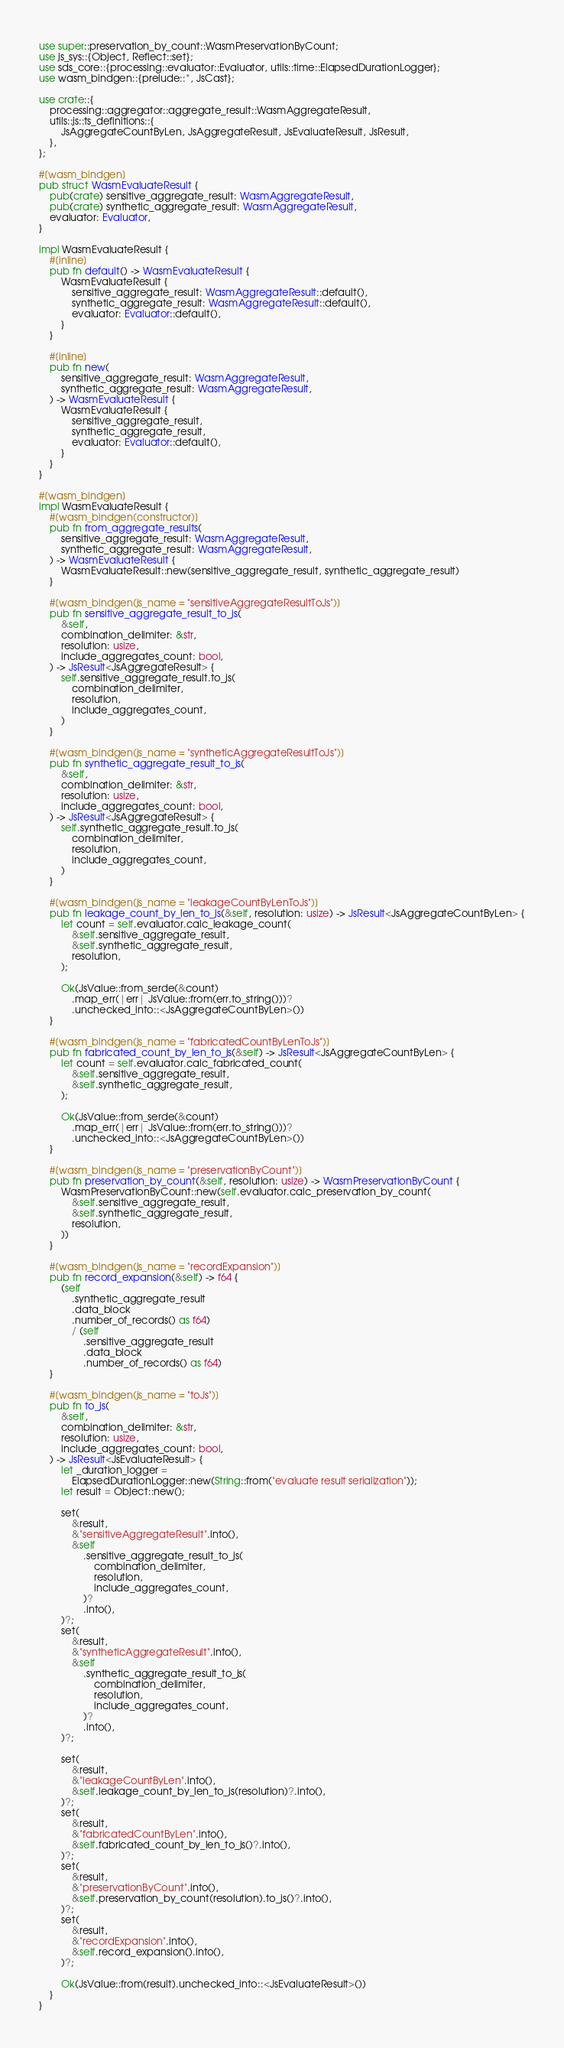<code> <loc_0><loc_0><loc_500><loc_500><_Rust_>use super::preservation_by_count::WasmPreservationByCount;
use js_sys::{Object, Reflect::set};
use sds_core::{processing::evaluator::Evaluator, utils::time::ElapsedDurationLogger};
use wasm_bindgen::{prelude::*, JsCast};

use crate::{
    processing::aggregator::aggregate_result::WasmAggregateResult,
    utils::js::ts_definitions::{
        JsAggregateCountByLen, JsAggregateResult, JsEvaluateResult, JsResult,
    },
};

#[wasm_bindgen]
pub struct WasmEvaluateResult {
    pub(crate) sensitive_aggregate_result: WasmAggregateResult,
    pub(crate) synthetic_aggregate_result: WasmAggregateResult,
    evaluator: Evaluator,
}

impl WasmEvaluateResult {
    #[inline]
    pub fn default() -> WasmEvaluateResult {
        WasmEvaluateResult {
            sensitive_aggregate_result: WasmAggregateResult::default(),
            synthetic_aggregate_result: WasmAggregateResult::default(),
            evaluator: Evaluator::default(),
        }
    }

    #[inline]
    pub fn new(
        sensitive_aggregate_result: WasmAggregateResult,
        synthetic_aggregate_result: WasmAggregateResult,
    ) -> WasmEvaluateResult {
        WasmEvaluateResult {
            sensitive_aggregate_result,
            synthetic_aggregate_result,
            evaluator: Evaluator::default(),
        }
    }
}

#[wasm_bindgen]
impl WasmEvaluateResult {
    #[wasm_bindgen(constructor)]
    pub fn from_aggregate_results(
        sensitive_aggregate_result: WasmAggregateResult,
        synthetic_aggregate_result: WasmAggregateResult,
    ) -> WasmEvaluateResult {
        WasmEvaluateResult::new(sensitive_aggregate_result, synthetic_aggregate_result)
    }

    #[wasm_bindgen(js_name = "sensitiveAggregateResultToJs")]
    pub fn sensitive_aggregate_result_to_js(
        &self,
        combination_delimiter: &str,
        resolution: usize,
        include_aggregates_count: bool,
    ) -> JsResult<JsAggregateResult> {
        self.sensitive_aggregate_result.to_js(
            combination_delimiter,
            resolution,
            include_aggregates_count,
        )
    }

    #[wasm_bindgen(js_name = "syntheticAggregateResultToJs")]
    pub fn synthetic_aggregate_result_to_js(
        &self,
        combination_delimiter: &str,
        resolution: usize,
        include_aggregates_count: bool,
    ) -> JsResult<JsAggregateResult> {
        self.synthetic_aggregate_result.to_js(
            combination_delimiter,
            resolution,
            include_aggregates_count,
        )
    }

    #[wasm_bindgen(js_name = "leakageCountByLenToJs")]
    pub fn leakage_count_by_len_to_js(&self, resolution: usize) -> JsResult<JsAggregateCountByLen> {
        let count = self.evaluator.calc_leakage_count(
            &self.sensitive_aggregate_result,
            &self.synthetic_aggregate_result,
            resolution,
        );

        Ok(JsValue::from_serde(&count)
            .map_err(|err| JsValue::from(err.to_string()))?
            .unchecked_into::<JsAggregateCountByLen>())
    }

    #[wasm_bindgen(js_name = "fabricatedCountByLenToJs")]
    pub fn fabricated_count_by_len_to_js(&self) -> JsResult<JsAggregateCountByLen> {
        let count = self.evaluator.calc_fabricated_count(
            &self.sensitive_aggregate_result,
            &self.synthetic_aggregate_result,
        );

        Ok(JsValue::from_serde(&count)
            .map_err(|err| JsValue::from(err.to_string()))?
            .unchecked_into::<JsAggregateCountByLen>())
    }

    #[wasm_bindgen(js_name = "preservationByCount")]
    pub fn preservation_by_count(&self, resolution: usize) -> WasmPreservationByCount {
        WasmPreservationByCount::new(self.evaluator.calc_preservation_by_count(
            &self.sensitive_aggregate_result,
            &self.synthetic_aggregate_result,
            resolution,
        ))
    }

    #[wasm_bindgen(js_name = "recordExpansion")]
    pub fn record_expansion(&self) -> f64 {
        (self
            .synthetic_aggregate_result
            .data_block
            .number_of_records() as f64)
            / (self
                .sensitive_aggregate_result
                .data_block
                .number_of_records() as f64)
    }

    #[wasm_bindgen(js_name = "toJs")]
    pub fn to_js(
        &self,
        combination_delimiter: &str,
        resolution: usize,
        include_aggregates_count: bool,
    ) -> JsResult<JsEvaluateResult> {
        let _duration_logger =
            ElapsedDurationLogger::new(String::from("evaluate result serialization"));
        let result = Object::new();

        set(
            &result,
            &"sensitiveAggregateResult".into(),
            &self
                .sensitive_aggregate_result_to_js(
                    combination_delimiter,
                    resolution,
                    include_aggregates_count,
                )?
                .into(),
        )?;
        set(
            &result,
            &"syntheticAggregateResult".into(),
            &self
                .synthetic_aggregate_result_to_js(
                    combination_delimiter,
                    resolution,
                    include_aggregates_count,
                )?
                .into(),
        )?;

        set(
            &result,
            &"leakageCountByLen".into(),
            &self.leakage_count_by_len_to_js(resolution)?.into(),
        )?;
        set(
            &result,
            &"fabricatedCountByLen".into(),
            &self.fabricated_count_by_len_to_js()?.into(),
        )?;
        set(
            &result,
            &"preservationByCount".into(),
            &self.preservation_by_count(resolution).to_js()?.into(),
        )?;
        set(
            &result,
            &"recordExpansion".into(),
            &self.record_expansion().into(),
        )?;

        Ok(JsValue::from(result).unchecked_into::<JsEvaluateResult>())
    }
}
</code> 